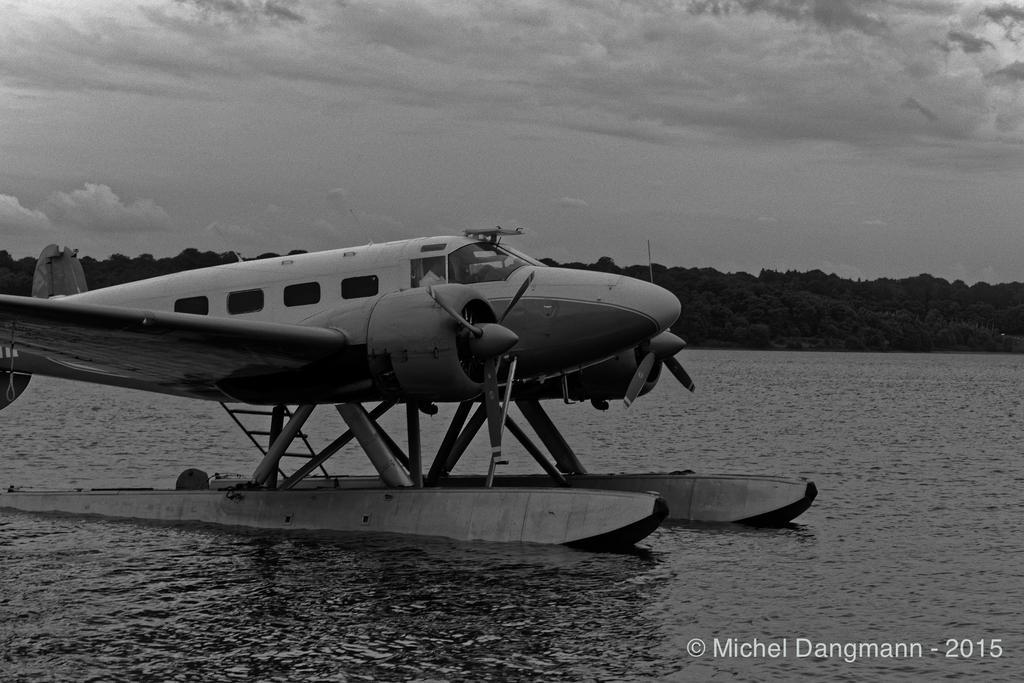How would you summarize this image in a sentence or two? It is the black and white image in which there is an aircraft in the water. In the background there are trees. At the top there is the sky. 